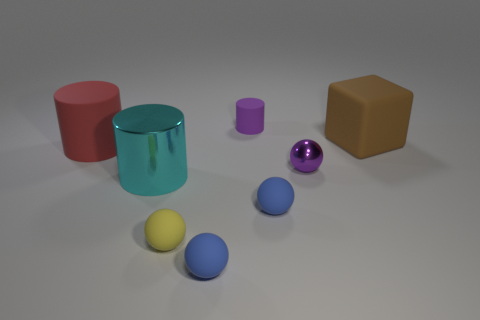Subtract all tiny shiny balls. How many balls are left? 3 Add 1 big blue blocks. How many objects exist? 9 Subtract all yellow cubes. How many blue balls are left? 2 Subtract 1 spheres. How many spheres are left? 3 Subtract all purple cylinders. How many cylinders are left? 2 Add 4 cyan metal objects. How many cyan metal objects are left? 5 Add 5 green matte spheres. How many green matte spheres exist? 5 Subtract 0 gray balls. How many objects are left? 8 Subtract all cylinders. How many objects are left? 5 Subtract all blue cubes. Subtract all green balls. How many cubes are left? 1 